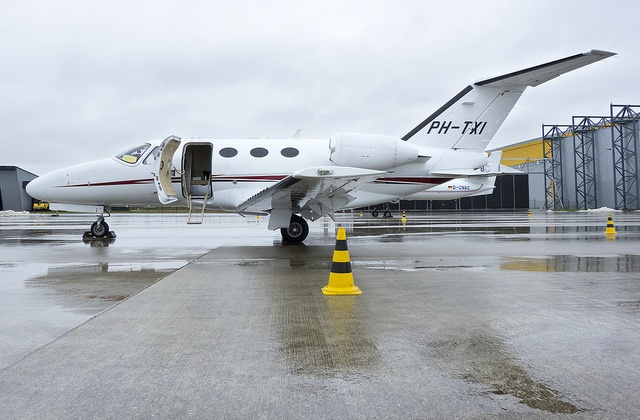Describe the objects in this image and their specific colors. I can see a airplane in white, lightgray, darkgray, gray, and black tones in this image. 